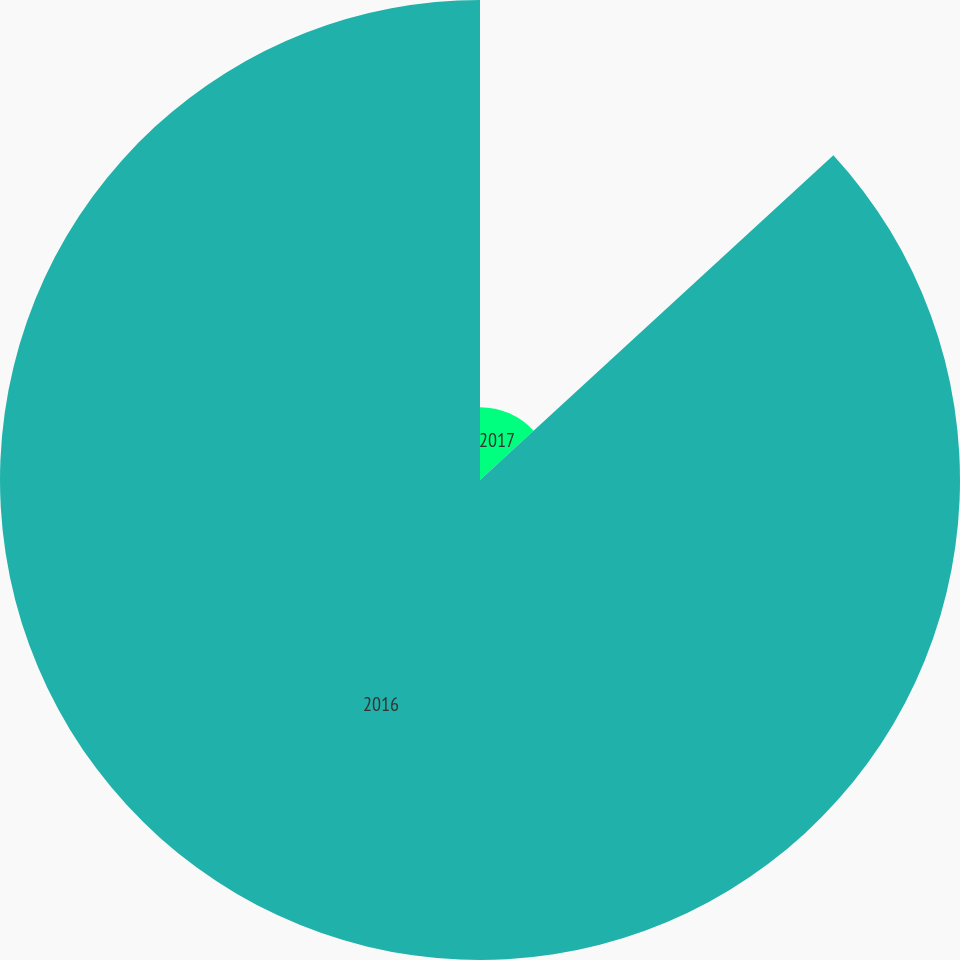Convert chart. <chart><loc_0><loc_0><loc_500><loc_500><pie_chart><fcel>2017<fcel>2016<nl><fcel>13.17%<fcel>86.83%<nl></chart> 